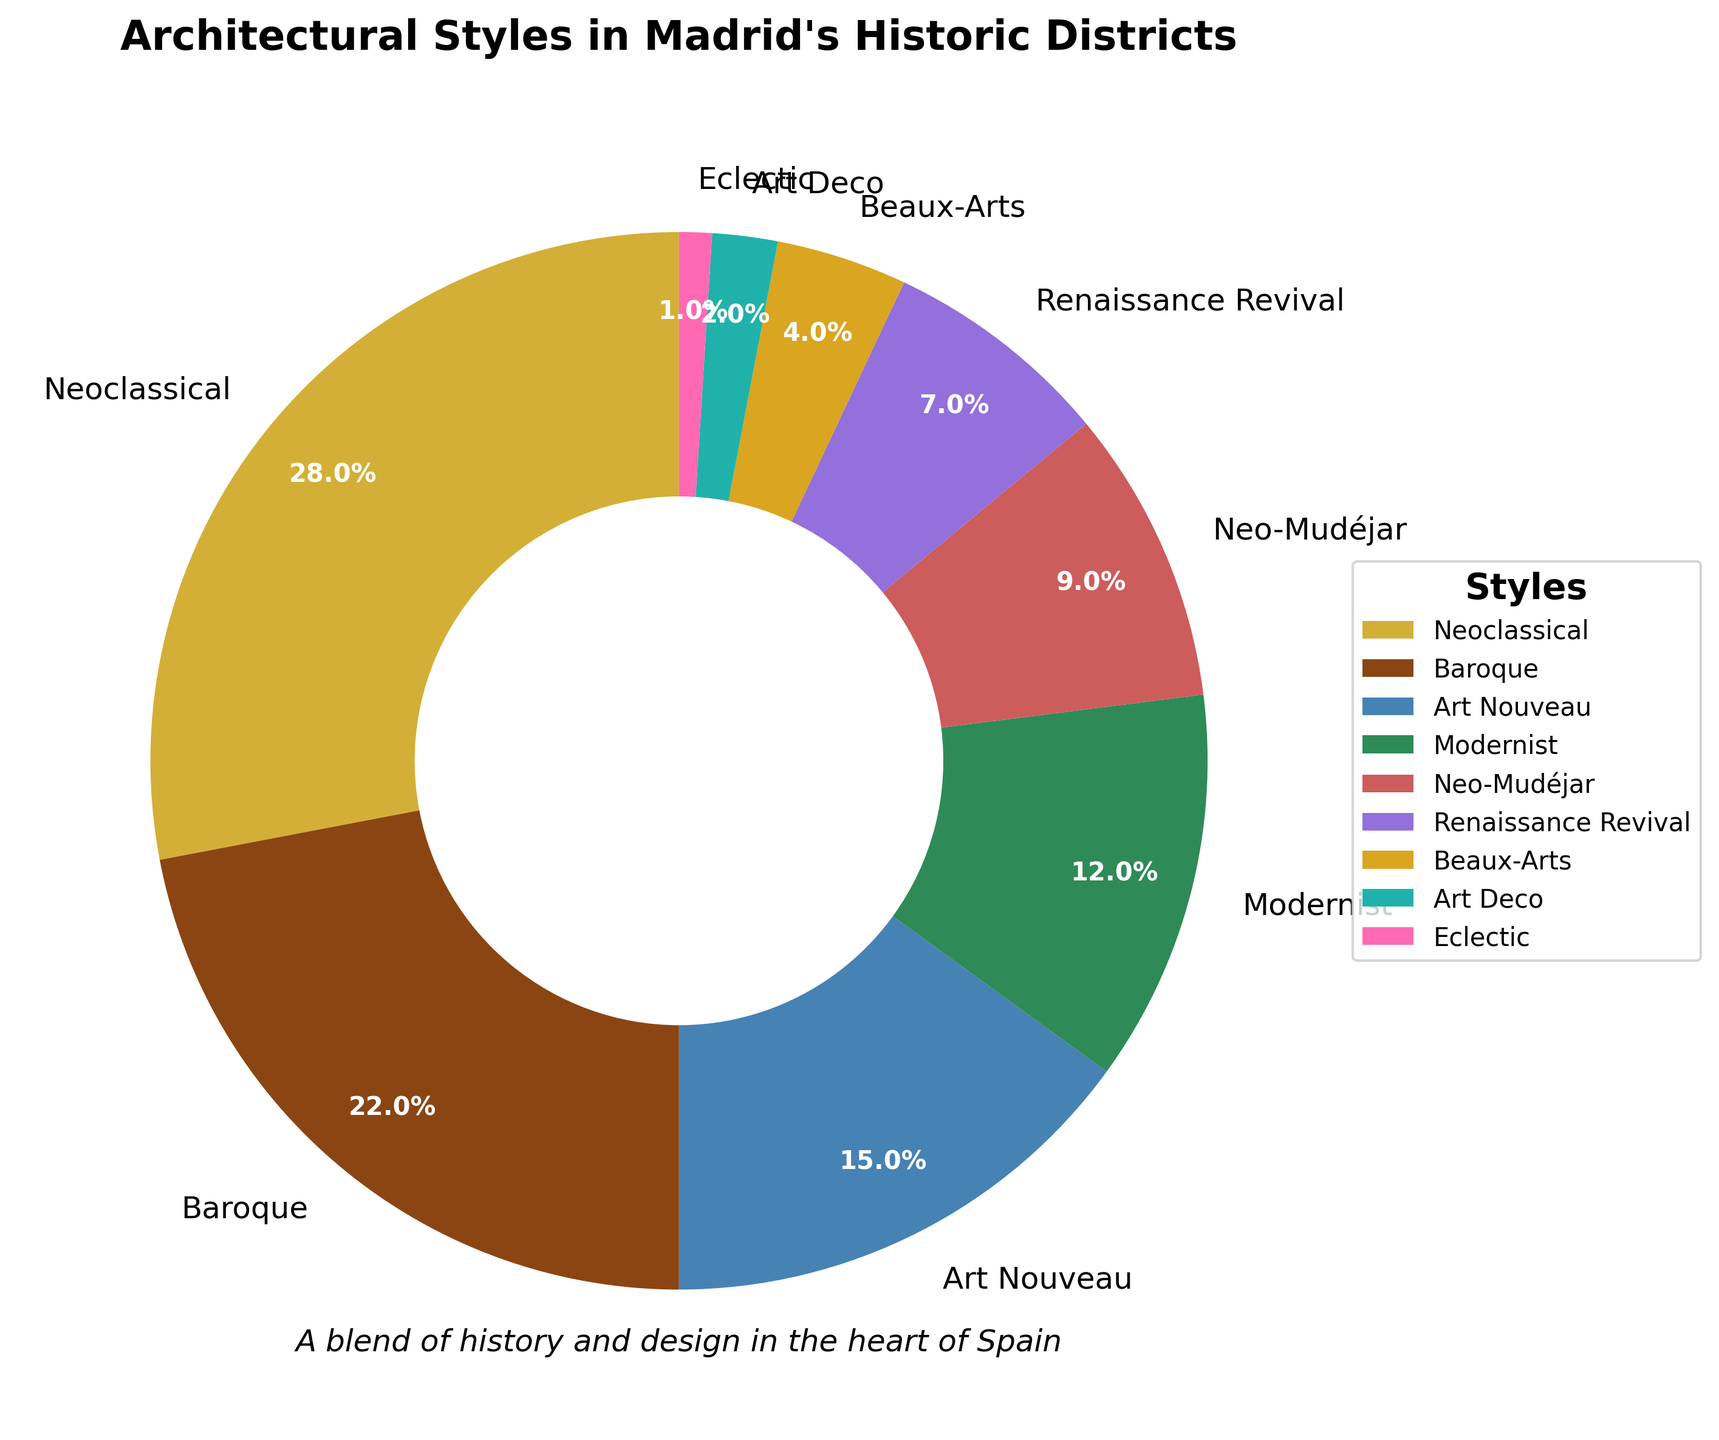Which architectural style has the largest percentage in Madrid's historic districts? The pie chart shows the breakdown of architectural styles by percentage. The largest wedge corresponds to Neoclassical with 28%.
Answer: Neoclassical What is the total percentage of Baroque and Neoclassical styles combined? From the figure, Baroque is 22% and Neoclassical is 28%. Adding these together, 22% + 28% = 50%.
Answer: 50% Which styles together make up more than half of Madrid's historic districts? The styles Neoclassical (28%) and Baroque (22%) together make 50%. Adding Art Nouveau (15%) makes 65%, which is more than half.
Answer: Neoclassical, Baroque, Art Nouveau Are there more Modernist or Neo-Mudéjar buildings in Madrid's historic districts? The pie chart shows Modernist at 12% and Neo-Mudéjar at 9%. Since 12% > 9%, there are more Modernist buildings.
Answer: Modernist What percentage difference exists between the least and most represented styles? The least represented style is Eclectic at 1%, and the most represented is Neoclassical at 28%. The difference is 28% - 1% = 27%.
Answer: 27% How many styles contribute to at least 10% each of the total composition? From the pie chart, Neoclassical (28%), Baroque (22%), Art Nouveau (15%), and Modernist (12%) each contribute at least 10%.
Answer: 4 Which style has the second smallest percentage? Eclectic is the smallest at 1%, and the next smallest is Art Deco at 2%.
Answer: Art Deco If you sum the percentages of Renaissance Revival, Beaux-Arts, and Art Deco, what do you get? The pie chart shows Renaissance Revival at 7%, Beaux-Arts at 4%, and Art Deco at 2%. Adding these gives 7% + 4% + 2% = 13%.
Answer: 13% Which wedge is represented by a green color in the pie chart? The pie chart uses green for the Modernist style, which is labeled as 12%.
Answer: Modernist (12%) Among the three least common styles, which one is the most common? The three least common styles are Art Deco (2%), Eclectic (1%), and Beaux-Arts (4%). The most common among these is Beaux-Arts at 4%.
Answer: Beaux-Arts (4%) 